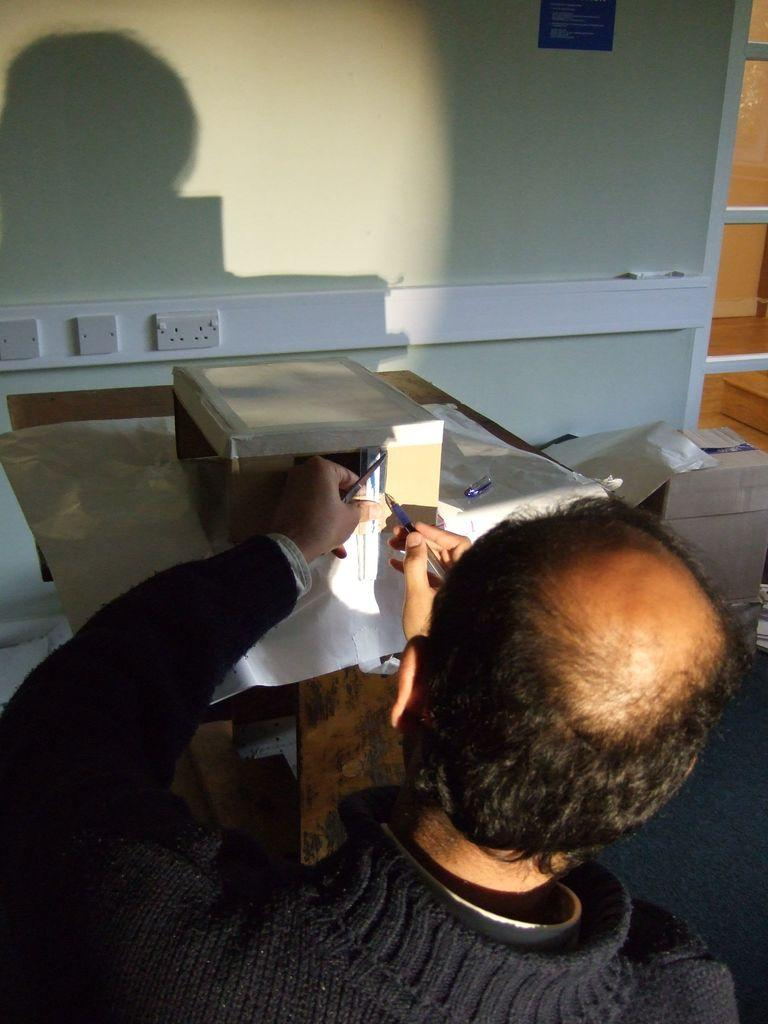Who is in the image? There is a person in the image. What is the person holding? The person is holding a pen. What is the main piece of furniture in the image? There is a table in the image. What is inside the box in the image? The facts do not specify what is inside the box, so we cannot answer that question definitively. What is on the table in the image? There are paper sheets and other objects on the table in the image. What can be seen in the background of the image? There is a wall, socket boards, and shelves in the background of the image. What type of flowers can be seen on the person's shirt in the image? There are no flowers visible on the person's shirt in the image. What is the purpose of the person holding the pen in the image? The facts do not specify the purpose of the person holding the pen, so we cannot answer that question definitively. 